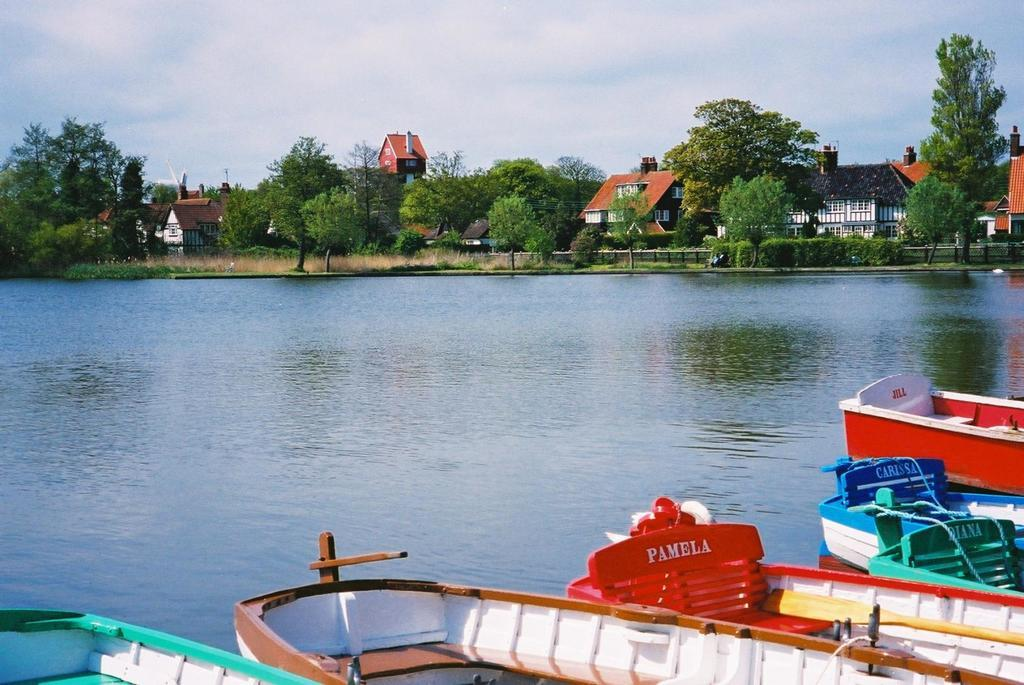What can be seen in the middle of the image? There is water in the middle of the image. What is located on the water in the image? There are boats on the water in the image. What can be seen in the background of the image? There are trees and houses in the background of the image. What is visible in the sky at the top of the image? There are clouds visible in the sky at the top of the image. What type of alarm can be heard going off in the image? There is no alarm present in the image, and therefore no sound can be heard. Can you tell me how many people are cooking in the image? There is no indication of cooking or people cooking in the image. 